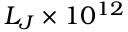Convert formula to latex. <formula><loc_0><loc_0><loc_500><loc_500>L _ { J } \times 1 0 ^ { 1 2 }</formula> 